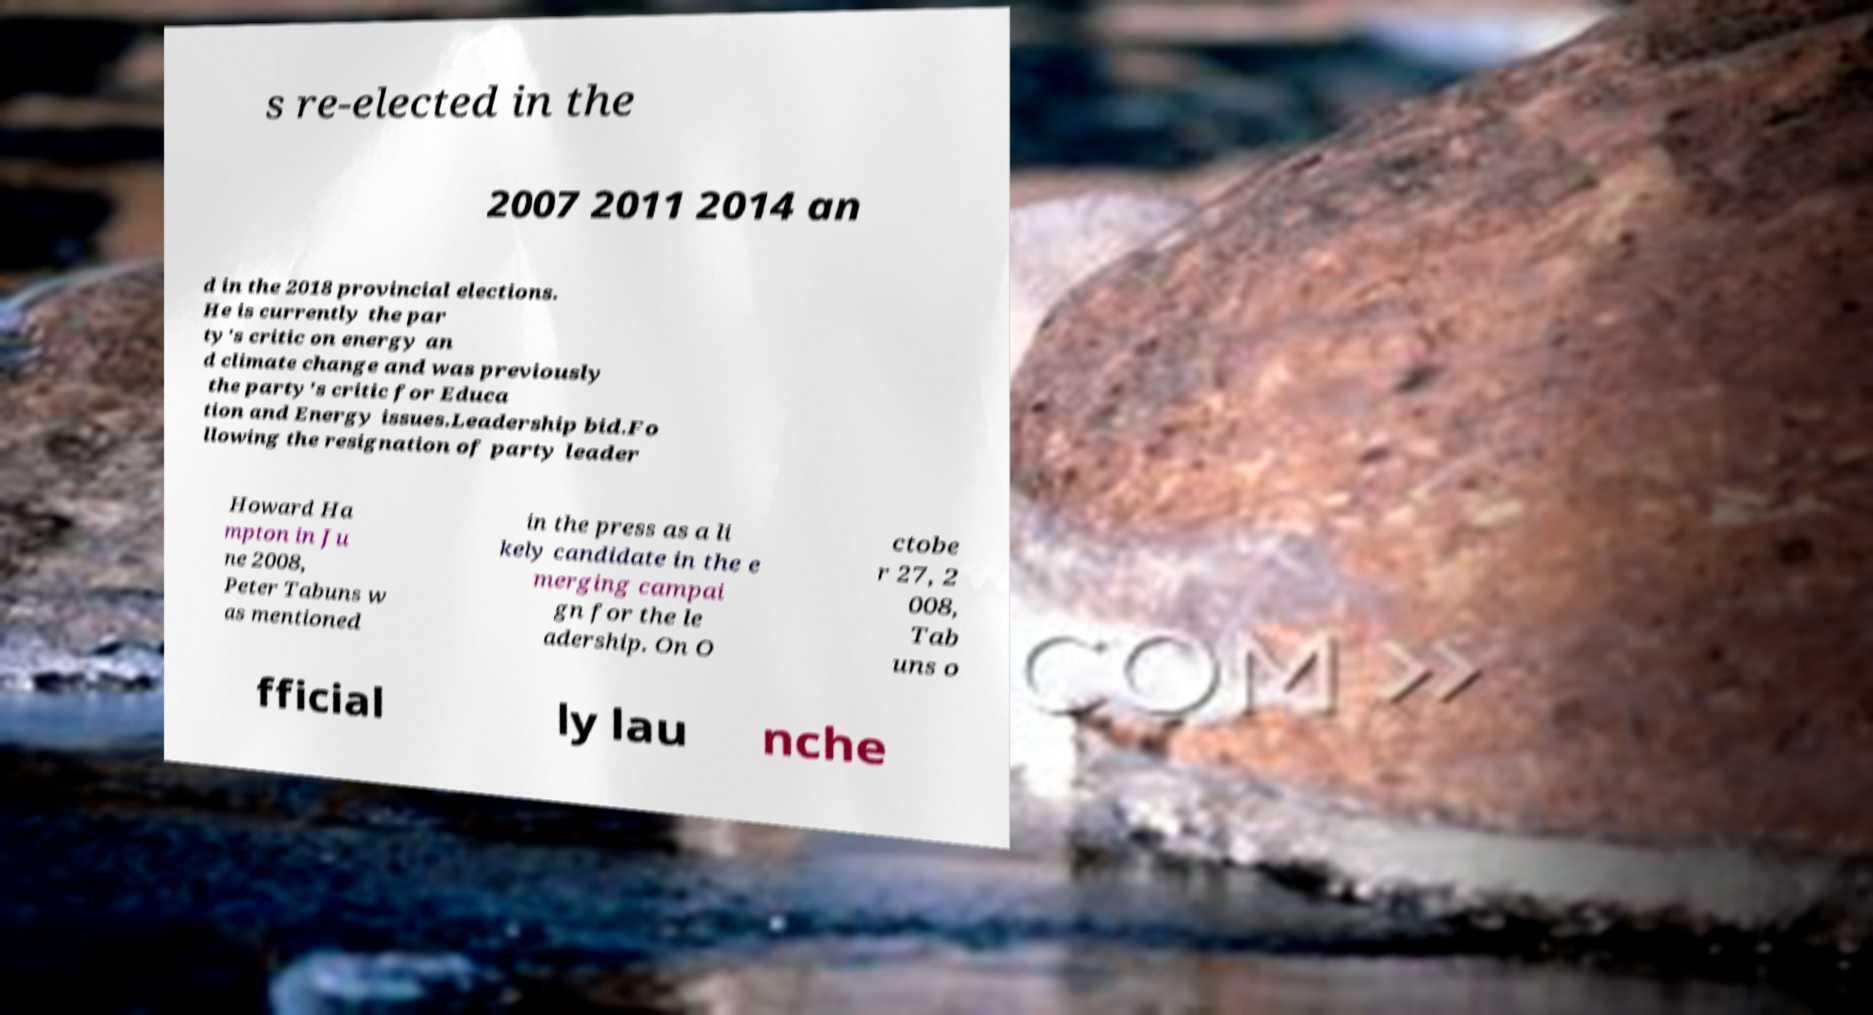Could you assist in decoding the text presented in this image and type it out clearly? s re-elected in the 2007 2011 2014 an d in the 2018 provincial elections. He is currently the par ty's critic on energy an d climate change and was previously the party's critic for Educa tion and Energy issues.Leadership bid.Fo llowing the resignation of party leader Howard Ha mpton in Ju ne 2008, Peter Tabuns w as mentioned in the press as a li kely candidate in the e merging campai gn for the le adership. On O ctobe r 27, 2 008, Tab uns o fficial ly lau nche 